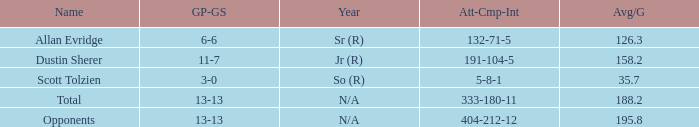Which quarterback had an Avg/G of 195.8? Opponents. 